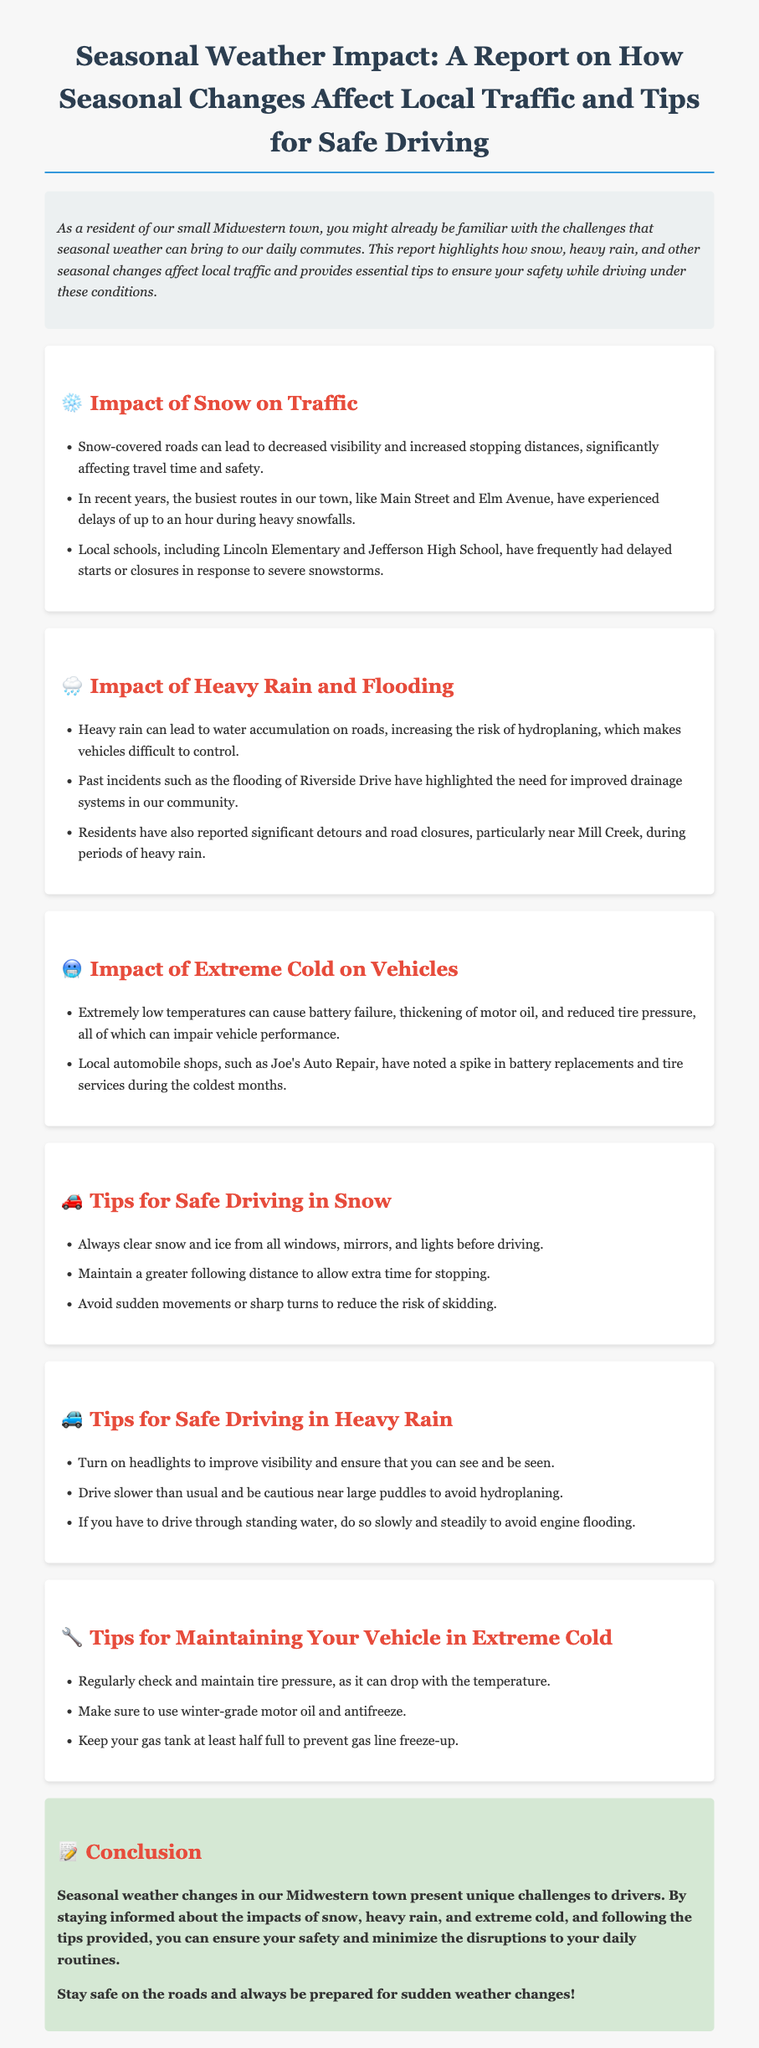What are some effects of snow on traffic? The document lists that snow-covered roads can lead to decreased visibility and increased stopping distances, significantly affecting travel time and safety.
Answer: Decreased visibility, increased stopping distances What major streets experienced delays during heavy snowfalls? The report specifically mentions that Main Street and Elm Avenue have experienced delays.
Answer: Main Street and Elm Avenue What should drivers do to maintain safe following distance in snow? According to the document, drivers should maintain a greater following distance to allow extra time for stopping.
Answer: Maintain greater following distance What is one impact of heavy rain on driving conditions? The document states that heavy rain can lead to water accumulation on roads, increasing the risk of hydroplaning.
Answer: Risk of hydroplaning What maintenance is recommended for vehicles in extreme cold? The report advises regularly checking and maintaining tire pressure, as it can drop with the temperature.
Answer: Regularly check tire pressure How frequently do local schools experience delays due to snow? The document mentions that local schools have frequently had delayed starts or closures due to severe snowstorms.
Answer: Frequently What happens to vehicles in extremely low temperatures? The report describes that extremely low temperatures can cause battery failure and thickening of motor oil.
Answer: Battery failure, thickening of motor oil What should drivers do when driving through standing water? The document advises that if you have to drive through standing water, do so slowly and steadily to avoid engine flooding.
Answer: Do so slowly and steadily What is one safety tip for driving in heavy rain? A key safety tip mentioned is to turn on headlights to improve visibility.
Answer: Turn on headlights 